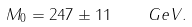Convert formula to latex. <formula><loc_0><loc_0><loc_500><loc_500>M _ { 0 } = 2 4 7 \pm 1 1 \quad G e V .</formula> 